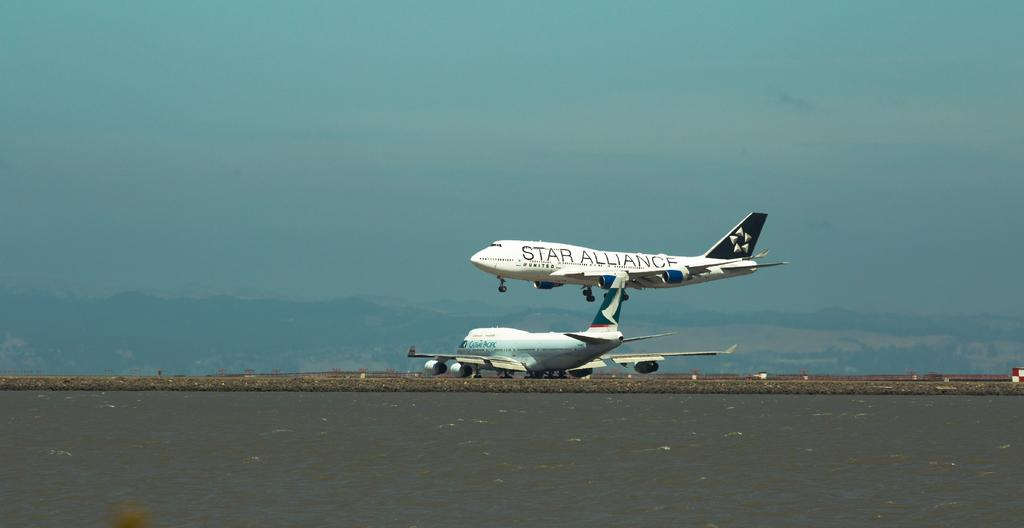<image>
Give a short and clear explanation of the subsequent image. A Star Alliance airplane is up in the air above another plane. 